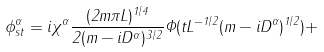<formula> <loc_0><loc_0><loc_500><loc_500>\phi ^ { \alpha } _ { s t } = i \chi ^ { \alpha } \frac { ( 2 m \pi L ) ^ { 1 / 4 } } { 2 ( m - i D ^ { \alpha } ) ^ { 3 / 2 } } \Phi ( t L ^ { - 1 / 2 } ( m - i D ^ { \alpha } ) ^ { 1 / 2 } ) +</formula> 